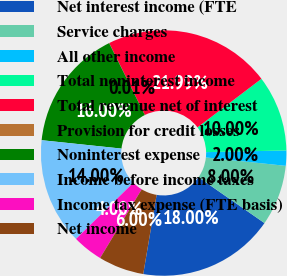Convert chart to OTSL. <chart><loc_0><loc_0><loc_500><loc_500><pie_chart><fcel>Net interest income (FTE<fcel>Service charges<fcel>All other income<fcel>Total noninterest income<fcel>Total revenue net of interest<fcel>Provision for credit losses<fcel>Noninterest expense<fcel>Income before income taxes<fcel>Income tax expense (FTE basis)<fcel>Net income<nl><fcel>18.0%<fcel>8.0%<fcel>2.0%<fcel>10.0%<fcel>21.99%<fcel>0.01%<fcel>16.0%<fcel>14.0%<fcel>4.0%<fcel>6.0%<nl></chart> 